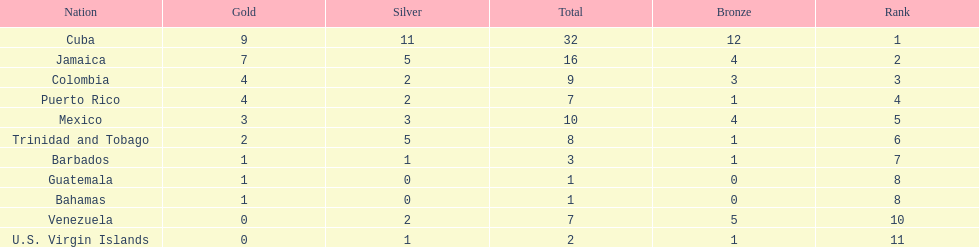The nation before mexico in the table Puerto Rico. Can you parse all the data within this table? {'header': ['Nation', 'Gold', 'Silver', 'Total', 'Bronze', 'Rank'], 'rows': [['Cuba', '9', '11', '32', '12', '1'], ['Jamaica', '7', '5', '16', '4', '2'], ['Colombia', '4', '2', '9', '3', '3'], ['Puerto Rico', '4', '2', '7', '1', '4'], ['Mexico', '3', '3', '10', '4', '5'], ['Trinidad and Tobago', '2', '5', '8', '1', '6'], ['Barbados', '1', '1', '3', '1', '7'], ['Guatemala', '1', '0', '1', '0', '8'], ['Bahamas', '1', '0', '1', '0', '8'], ['Venezuela', '0', '2', '7', '5', '10'], ['U.S. Virgin Islands', '0', '1', '2', '1', '11']]} 